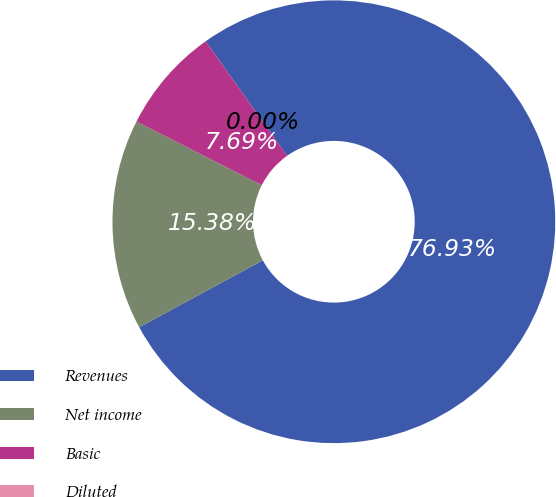Convert chart to OTSL. <chart><loc_0><loc_0><loc_500><loc_500><pie_chart><fcel>Revenues<fcel>Net income<fcel>Basic<fcel>Diluted<nl><fcel>76.92%<fcel>15.38%<fcel>7.69%<fcel>0.0%<nl></chart> 